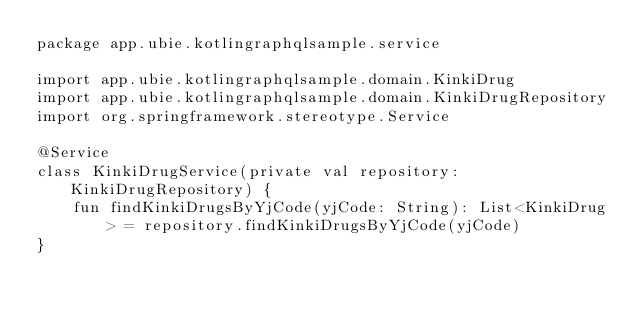<code> <loc_0><loc_0><loc_500><loc_500><_Kotlin_>package app.ubie.kotlingraphqlsample.service

import app.ubie.kotlingraphqlsample.domain.KinkiDrug
import app.ubie.kotlingraphqlsample.domain.KinkiDrugRepository
import org.springframework.stereotype.Service

@Service
class KinkiDrugService(private val repository: KinkiDrugRepository) {
    fun findKinkiDrugsByYjCode(yjCode: String): List<KinkiDrug> = repository.findKinkiDrugsByYjCode(yjCode)
}</code> 